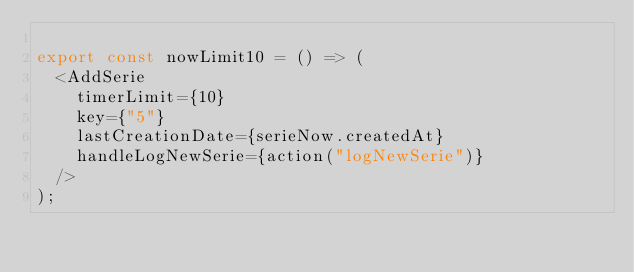Convert code to text. <code><loc_0><loc_0><loc_500><loc_500><_TypeScript_>
export const nowLimit10 = () => (
  <AddSerie
    timerLimit={10}
    key={"5"}
    lastCreationDate={serieNow.createdAt}
    handleLogNewSerie={action("logNewSerie")}
  />
);
</code> 